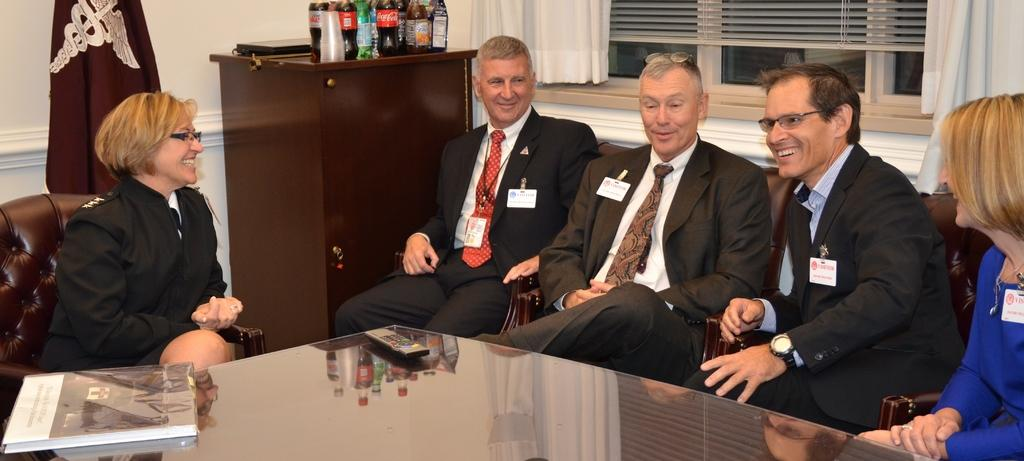Who or what can be seen in the image? There are people in the image. What object is on the table in the image? There is a remote and a book on the table. What items are on the cupboard in the image? There are bottles and glasses on the cupboard. Can you describe the objects on the cupboard? There are objects on the cupboard, but their specific details are not mentioned in the facts. What type of window treatment is present in the image? There are curtains in the image. How many windows are visible in the image? There are windows in the image. How many horses can be seen in the image? There are no horses present in the image. What type of rod is used to hold the shirt in the image? There is no shirt or rod present in the image. 